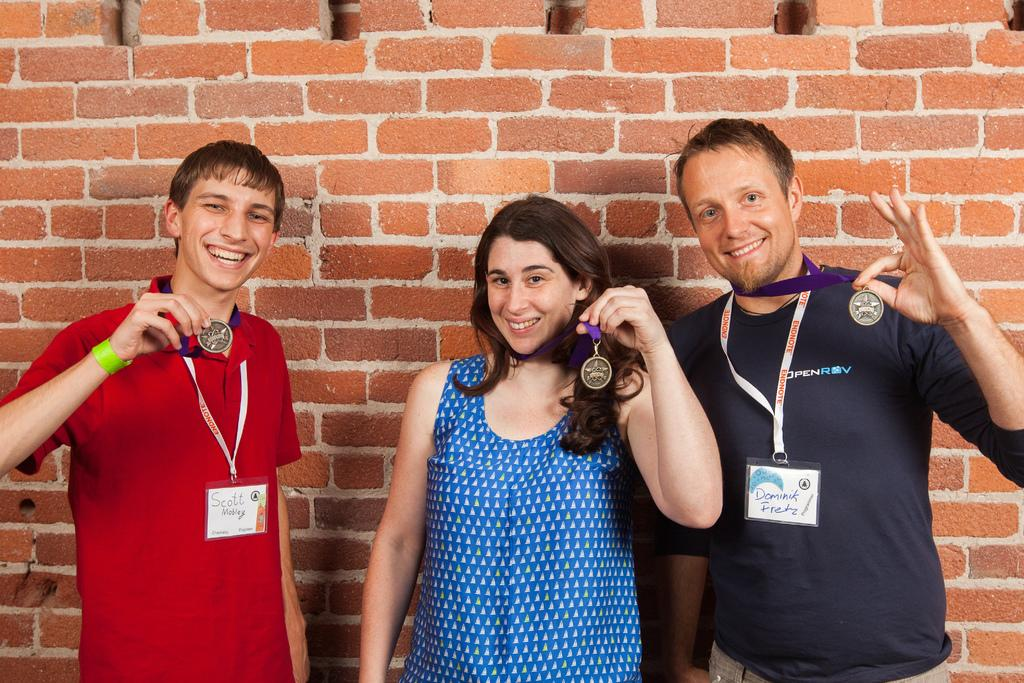How many people are in the image? There are three people in the image. What are the people doing in the image? The people are showing their medals and posing for a picture. What can be seen in the background of the image? There is a brick wall in the background of the image. What type of skirt is the servant wearing in the image? There is no servant or skirt present in the image. 